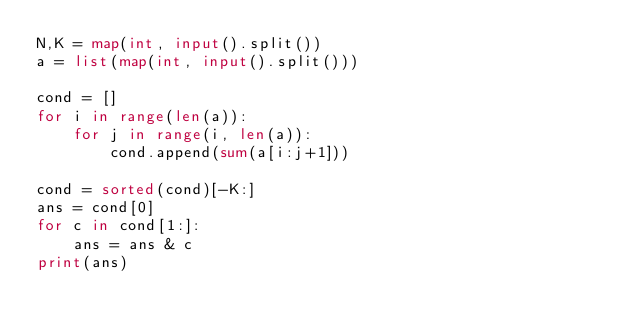<code> <loc_0><loc_0><loc_500><loc_500><_Python_>N,K = map(int, input().split())
a = list(map(int, input().split()))

cond = []
for i in range(len(a)):
    for j in range(i, len(a)):
        cond.append(sum(a[i:j+1]))

cond = sorted(cond)[-K:]
ans = cond[0]
for c in cond[1:]:
    ans = ans & c
print(ans)</code> 